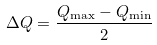<formula> <loc_0><loc_0><loc_500><loc_500>\Delta Q = \frac { Q _ { \max } - Q _ { \min } } { 2 }</formula> 